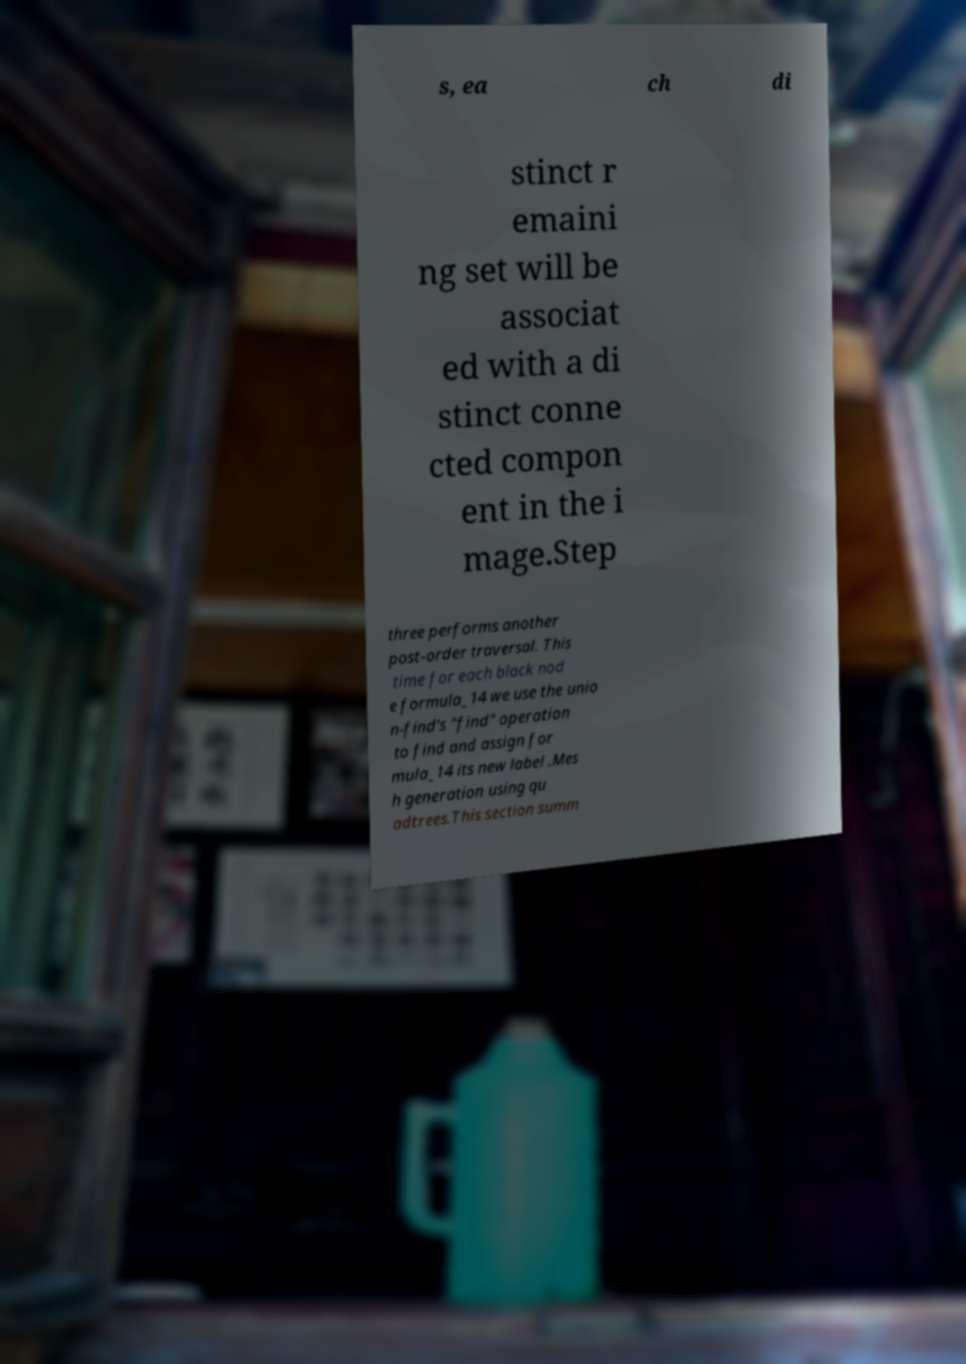Could you assist in decoding the text presented in this image and type it out clearly? s, ea ch di stinct r emaini ng set will be associat ed with a di stinct conne cted compon ent in the i mage.Step three performs another post-order traversal. This time for each black nod e formula_14 we use the unio n-find's "find" operation to find and assign for mula_14 its new label .Mes h generation using qu adtrees.This section summ 